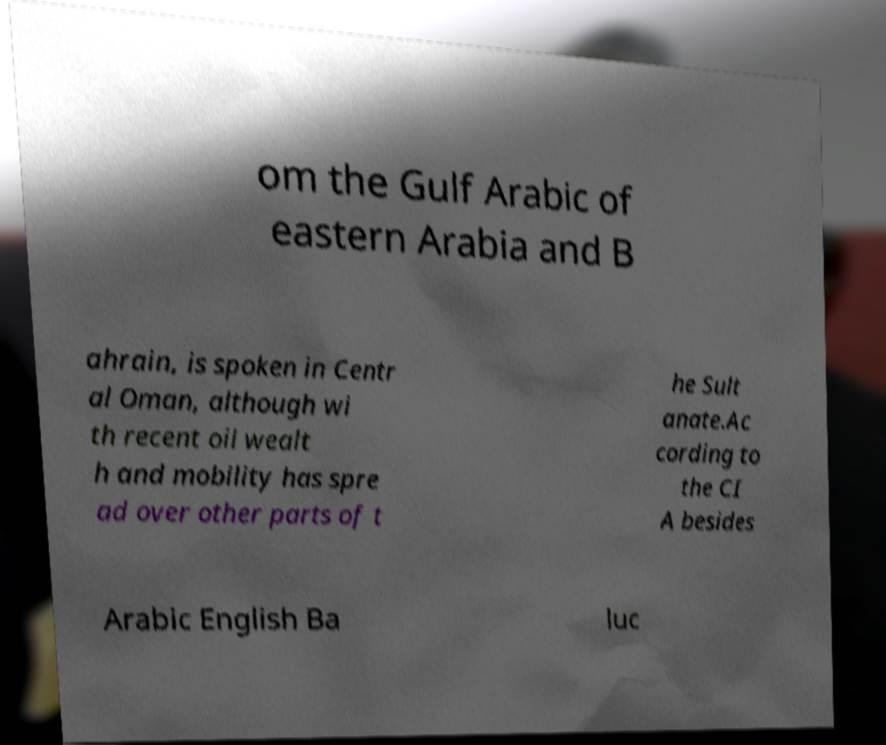What messages or text are displayed in this image? I need them in a readable, typed format. om the Gulf Arabic of eastern Arabia and B ahrain, is spoken in Centr al Oman, although wi th recent oil wealt h and mobility has spre ad over other parts of t he Sult anate.Ac cording to the CI A besides Arabic English Ba luc 